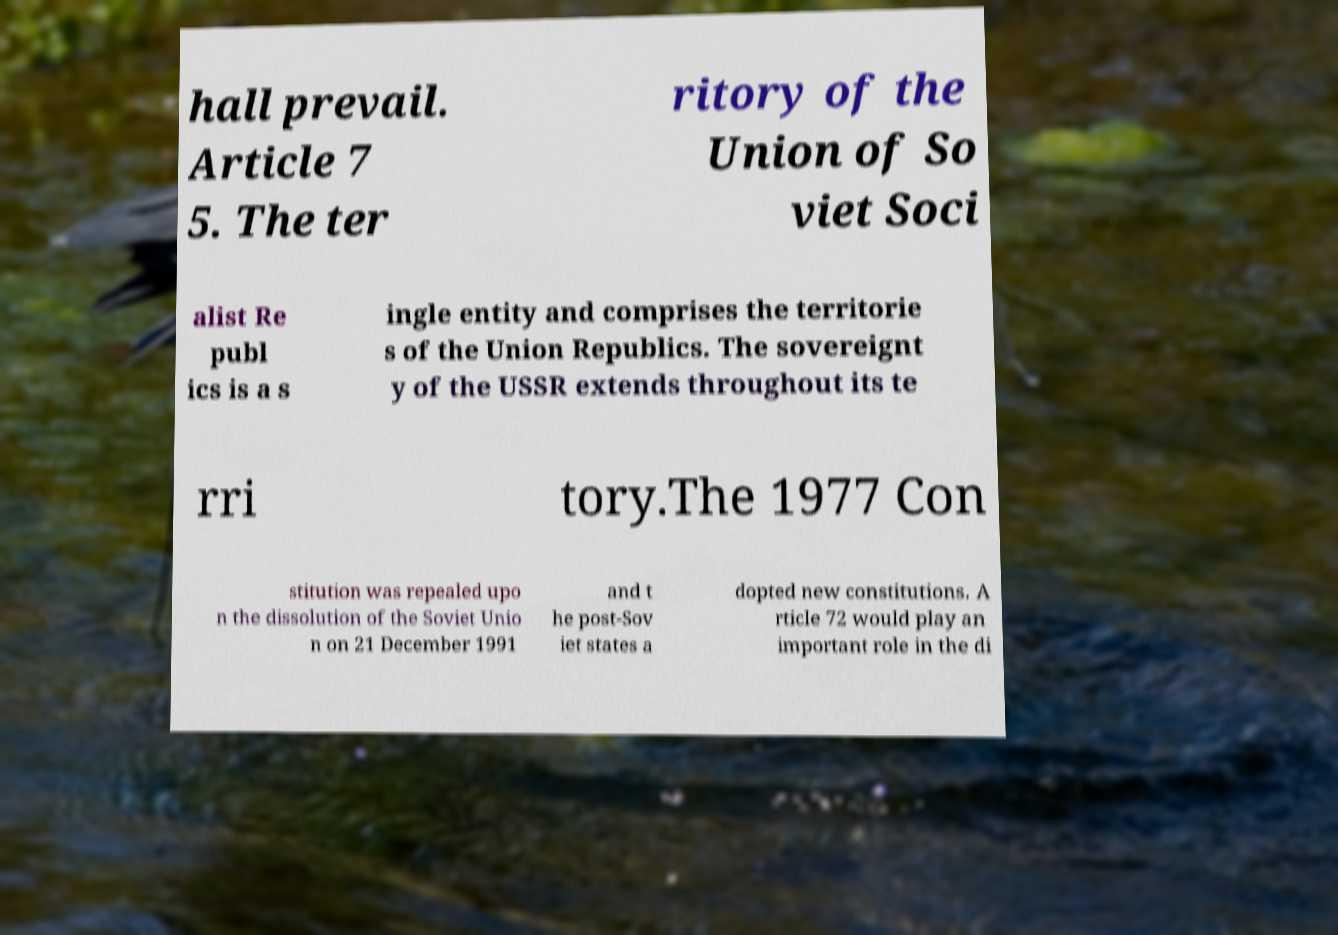Can you accurately transcribe the text from the provided image for me? hall prevail. Article 7 5. The ter ritory of the Union of So viet Soci alist Re publ ics is a s ingle entity and comprises the territorie s of the Union Republics. The sovereignt y of the USSR extends throughout its te rri tory.The 1977 Con stitution was repealed upo n the dissolution of the Soviet Unio n on 21 December 1991 and t he post-Sov iet states a dopted new constitutions. A rticle 72 would play an important role in the di 